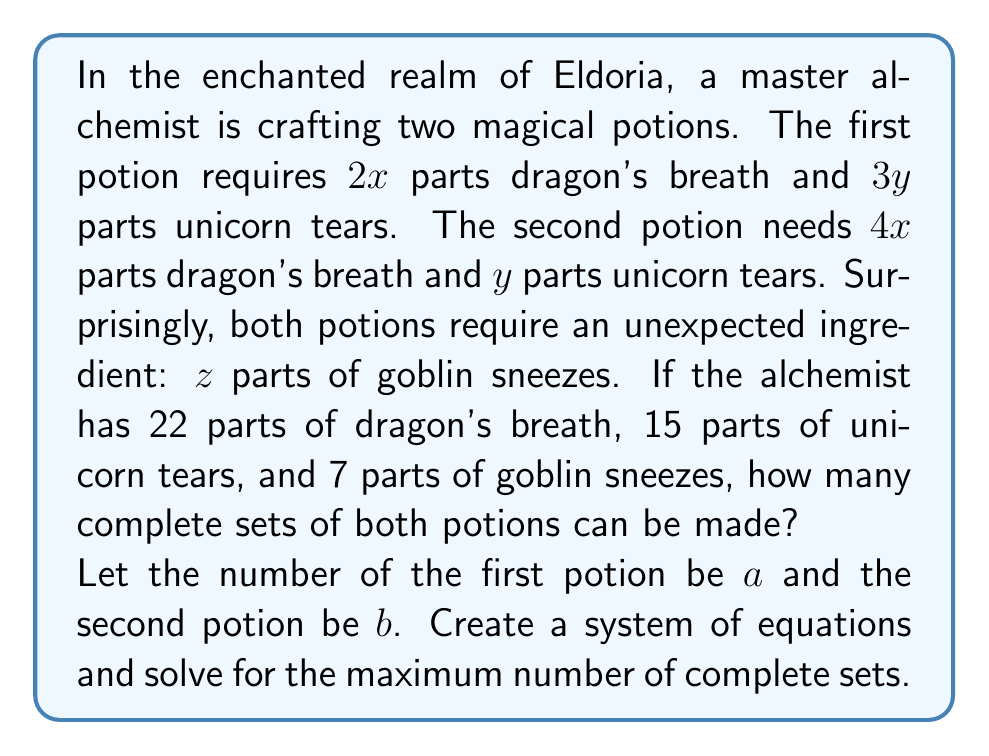Show me your answer to this math problem. Let's approach this step-by-step:

1) First, let's set up our system of equations based on the given information:

   Dragon's breath: $2x * a + 4x * b = 22$
   Unicorn tears: $3y * a + y * b = 15$
   Goblin sneezes: $z * a + z * b = 7$

2) Simplify the first two equations:
   
   $2a + 4b = 22$ (1)
   $3a + b = 15$ (2)

3) From equation (3), we can see that $a + b = 7$

4) Multiply equation (2) by 2:
   
   $6a + 2b = 30$ (4)

5) Subtract equation (1) from equation (4):
   
   $4a - 2b = 8$

6) Add this to $2(a + b = 7)$:
   
   $6a = 22$

7) Solve for $a$:
   
   $a = \frac{22}{6} = \frac{11}{3}$

8) Substitute this into $a + b = 7$:
   
   $\frac{11}{3} + b = 7$
   $b = 7 - \frac{11}{3} = \frac{10}{3}$

9) Since we need complete sets, we must round down to the nearest whole number:

   $a = 3$ and $b = 3$

10) Verify:
    Dragon's breath: $2(3) + 4(3) = 6 + 12 = 18 \leq 22$
    Unicorn tears: $3(3) + 1(3) = 9 + 3 = 12 \leq 15$
    Goblin sneezes: $1(3) + 1(3) = 3 + 3 = 6 \leq 7$

Therefore, the maximum number of complete sets is 3.
Answer: 3 complete sets 